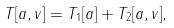<formula> <loc_0><loc_0><loc_500><loc_500>T [ a , v ] = T _ { 1 } [ a ] + T _ { 2 } [ a , v ] ,</formula> 